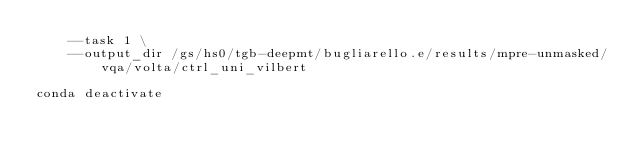Convert code to text. <code><loc_0><loc_0><loc_500><loc_500><_Bash_>	--task 1 \
	--output_dir /gs/hs0/tgb-deepmt/bugliarello.e/results/mpre-unmasked/vqa/volta/ctrl_uni_vilbert

conda deactivate
</code> 